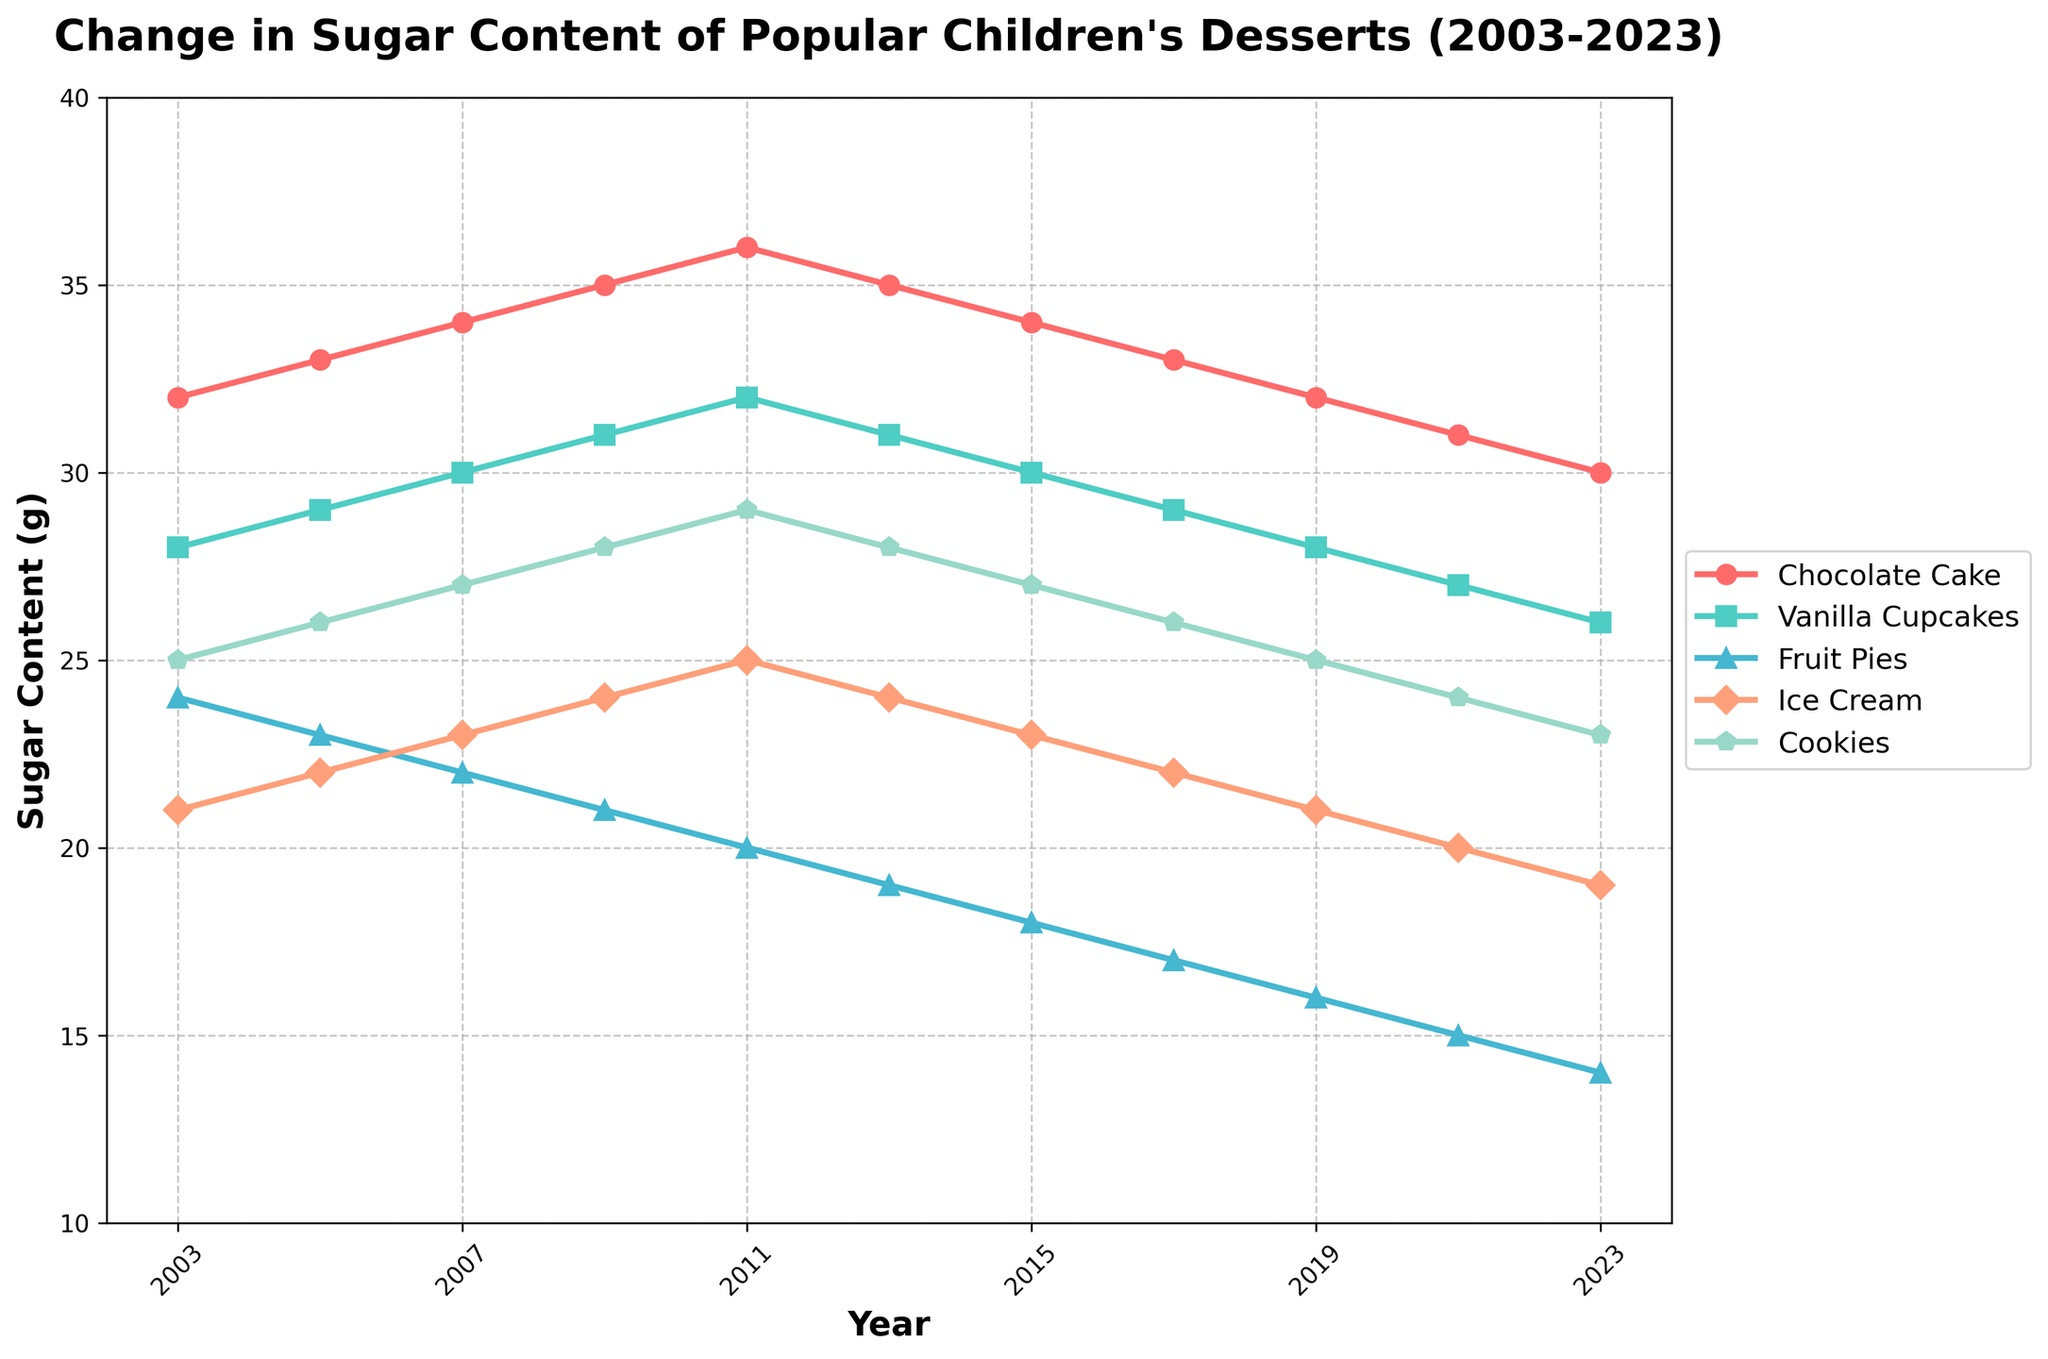Which dessert had the highest sugar content in 2023? In 2023, look at the data points for each dessert and find the highest one. Chocolate cake has the highest sugar content with 30g.
Answer: Chocolate cake How did the sugar content of vanilla cupcakes change from 2003 to 2023? Locate the data points for vanilla cupcakes in 2003 and 2023. Subtract the older value (28g) from the new value (26g), indicating a decrease.
Answer: Decrease by 2g Which dessert shows the largest overall decrease in sugar content over the 20-year period? Compare the sugar content changes for all desserts from 2003 to 2023. Fruit pies decreased from 24g to 14g, a total decrease of 10g, which is the largest.
Answer: Fruit pies What is the average sugar content of ice cream from 2003 to 2023? Sum the sugar content values for ice cream (21+22+23+24+25+24+23+22+21+20+19) and divide by the number of data points (11). The total is 244, so the average is 244/11.
Answer: Approximately 22.2g Between which two years did cookies show the largest yearly decrease in sugar content? Calculate the yearly differences for cookies sugar content and find the year with the largest decrease. The biggest drop occurred between 2021 (24g) and 2023 (23g) with a decrease of 1g.
Answer: 2021 to 2023 Which dessert had a consistent yearly decrease in sugar content from 2003 to 2023? Check the trend of each dessert. Fruit pies show a consistent yearly decrease in sugar content as the line has a downward slope throughout.
Answer: Fruit pies How many total data points are there on the plot? Each dessert from 2003 to 2023 has 11 data points, and there are 5 desserts. Therefore, the total number is 11 * 5 = 55 data points.
Answer: 55 What is the median sugar content of chocolate cake over the last 20 years? List all sugar contents for chocolate cake (32, 33, 34, 35, 36, 35, 34, 33, 32, 31, 30), then find the middle value. The sorted values give a median of 34.
Answer: 34 In which year did all desserts show a decrease in sugar content compared to the previous year? Comparing each year's sugar content with the previous year for each dessert, observe the trend. In 2013, all desserts show a decrease compared to 2011.
Answer: 2013 